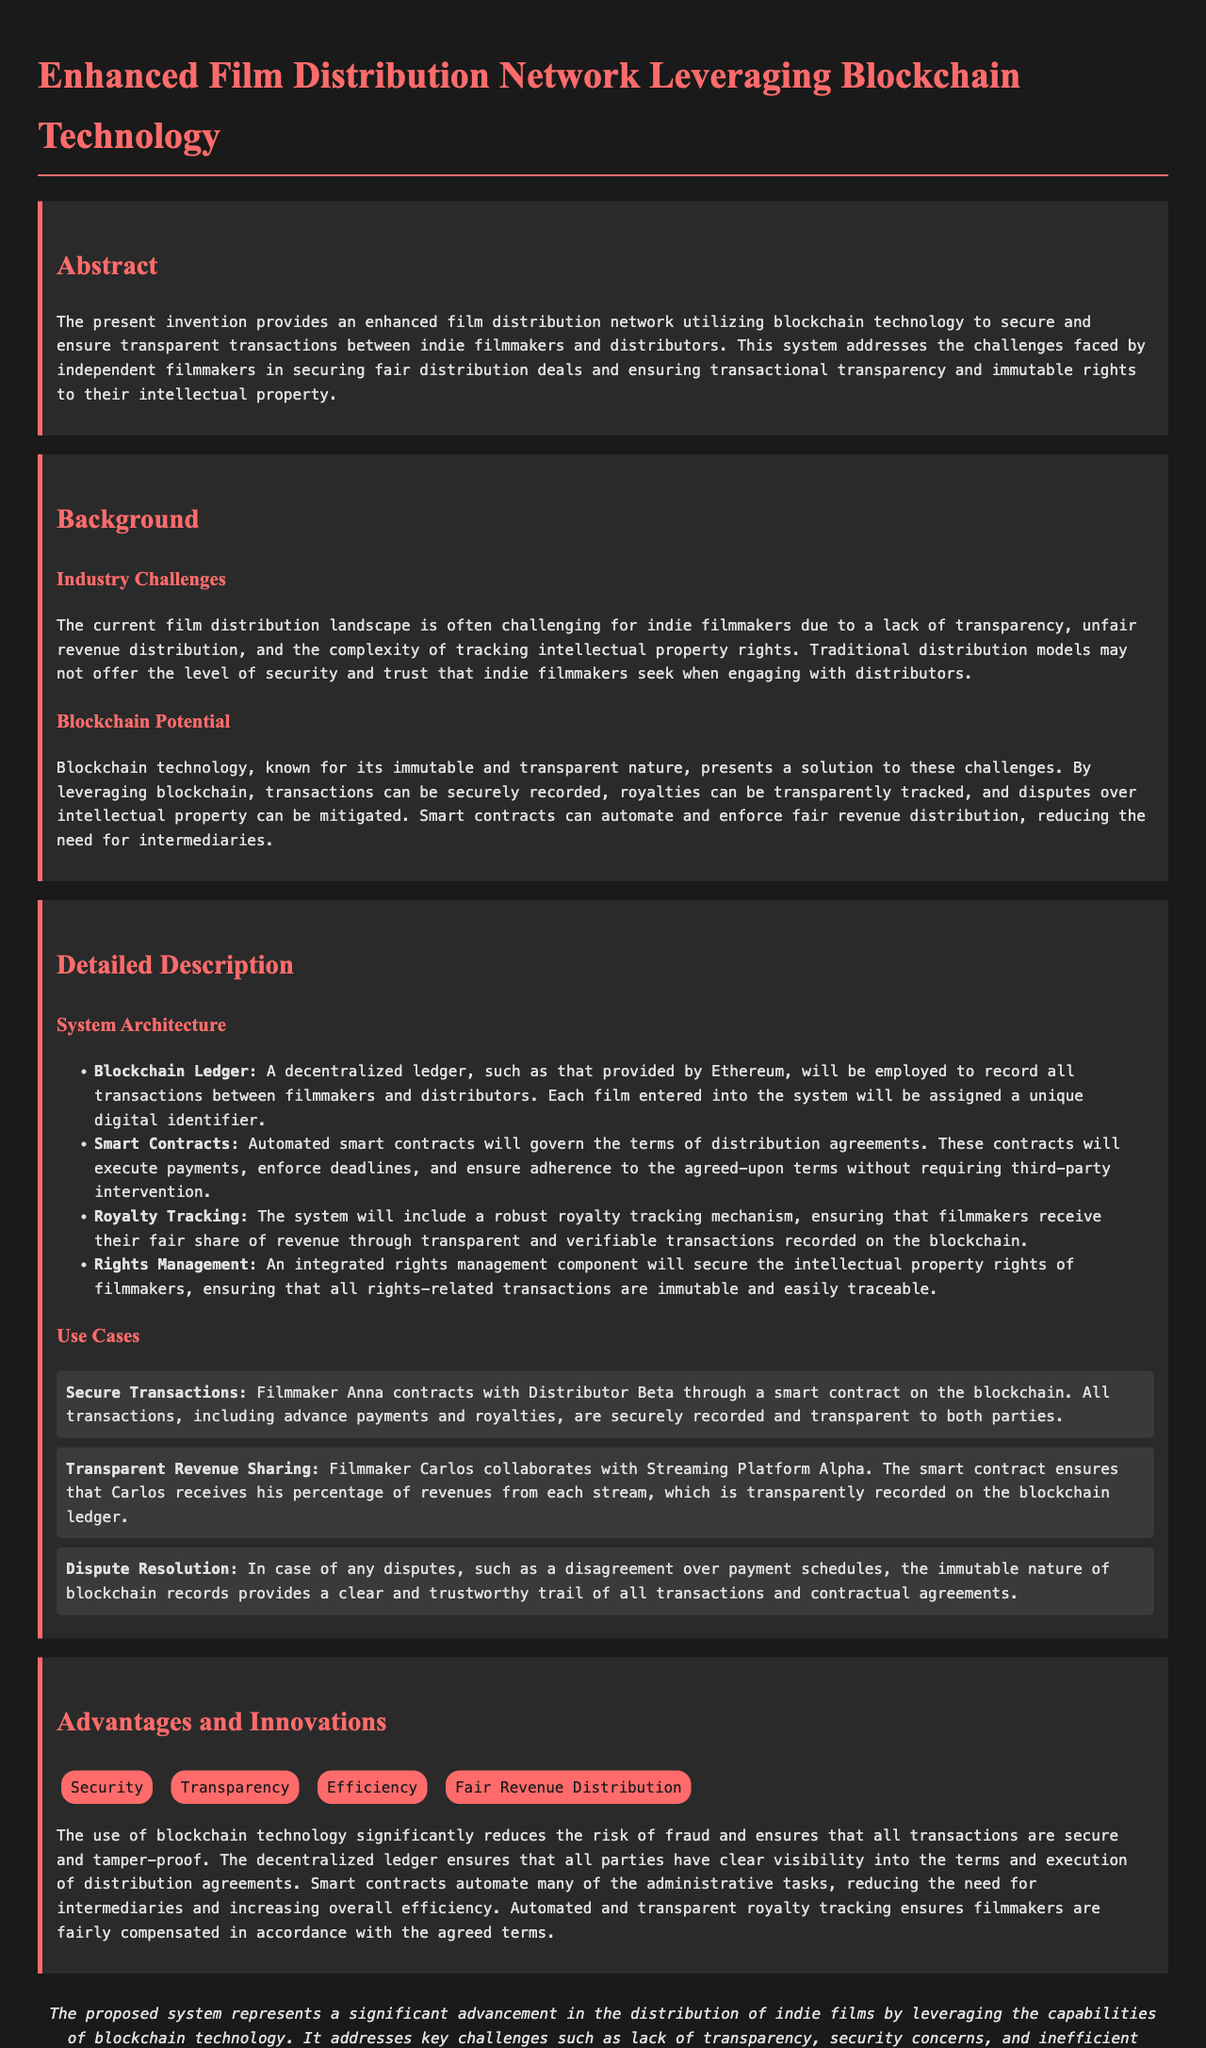What technology does the invention utilize? The invention utilizes blockchain technology to ensure secure and transparent transactions.
Answer: blockchain technology What is one industry challenge mentioned for indie filmmakers? The document states that a challenge faced by indie filmmakers is a lack of transparency in the distribution landscape.
Answer: lack of transparency How does the system ensure fair revenue distribution? The system automates and enforces fair revenue distribution through smart contracts that execute payments.
Answer: smart contracts What component secures intellectual property rights? An integrated rights management component secures the intellectual property rights of filmmakers.
Answer: rights management Which platform did Filmmaker Carlos collaborate with? Filmmaker Carlos collaborated with Streaming Platform Alpha according to the use case mentioned.
Answer: Streaming Platform Alpha What is one advantage of using the proposed system? The proposed system's advantage includes transparency in transactions as per the section discussing advantages.
Answer: Transparency How are disputes resolved within the system? Disputes are resolved by the immutable nature of blockchain records providing a clear and trustworthy trail.
Answer: immutable nature of blockchain What is the title of this patent application? The title of the document is “Enhanced Film Distribution Network Leveraging Blockchain Technology.”
Answer: Enhanced Film Distribution Network Leveraging Blockchain Technology What is the main purpose of smart contracts in this system? Smart contracts in this system are designed to automate and enforce the terms of distribution agreements.
Answer: automate and enforce terms 